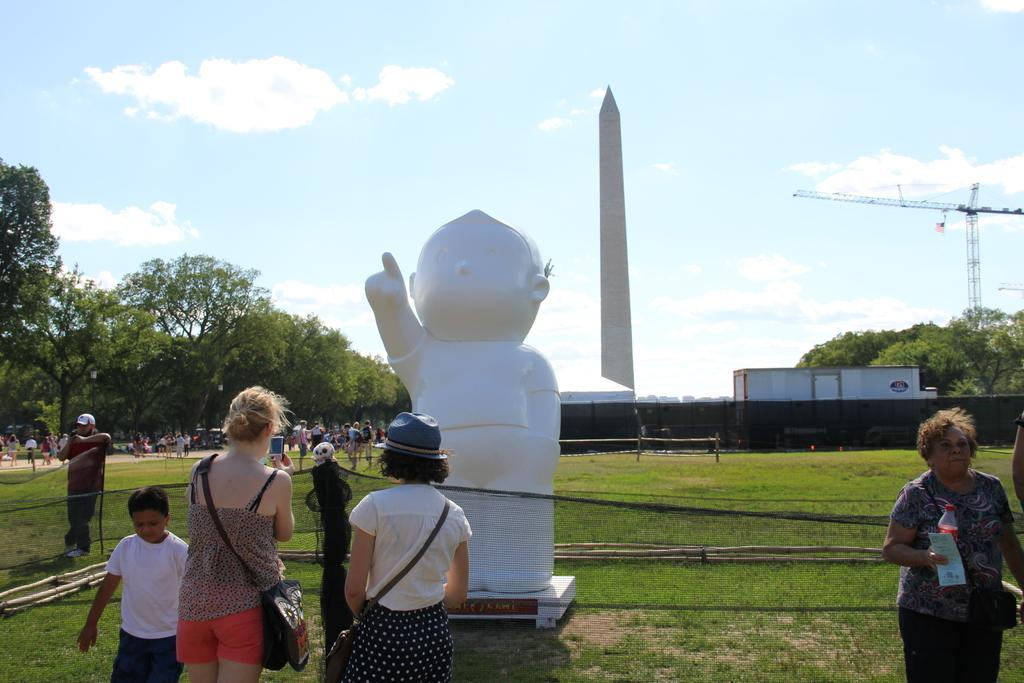How many people are present in the image? There are many people in the image. What is at the bottom of the image? There is green grass at the bottom of the image. What can be found in the middle of the image? There is a statue in the middle of the image. What is visible in the background of the image? There are trees in the background of the image. What type of sofa can be seen floating in space in the image? There is no sofa or space present in the image; it features a statue surrounded by people and trees. How many rays are visible coming from the statue in the image? There are no rays visible coming from the statue in the image. 